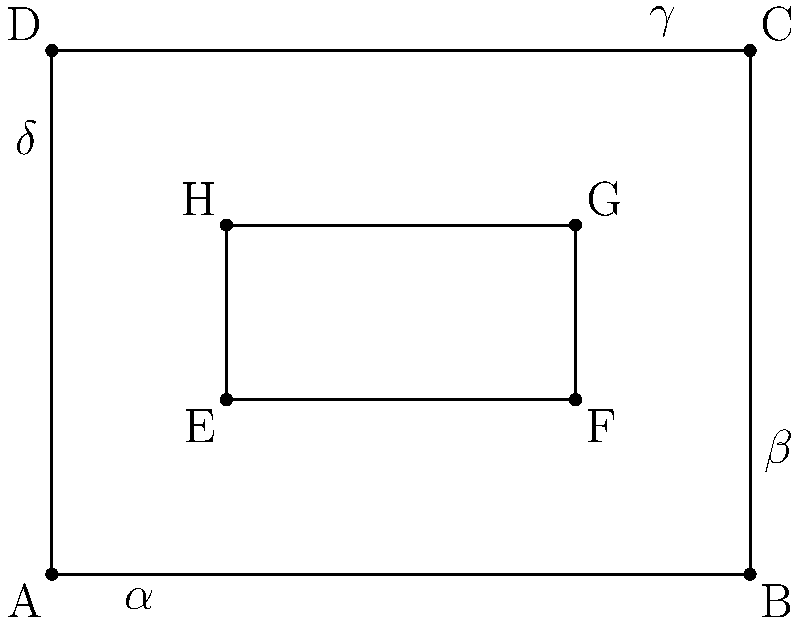In your high-end recording studio, you're designing an acoustic treatment layout. The room is represented by rectangle ABCD, with a sound-absorbing panel represented by rectangle EFGH. Angles $\alpha$, $\beta$, $\gamma$, and $\delta$ are formed at the corners of the room. Which pairs of angles are congruent, and why is this important for achieving balanced sound reflection? To determine the congruent angles and understand their importance in acoustic treatment, let's follow these steps:

1. Identify the shape of the room:
   The room is represented by rectangle ABCD.

2. Properties of a rectangle:
   - All interior angles of a rectangle are 90°.
   - Opposite sides are parallel and equal in length.

3. Congruent angles:
   - $\angle \alpha \cong \angle \gamma$ (opposite angles)
   - $\angle \beta \cong \angle \delta$ (opposite angles)

4. Why these angles are congruent:
   In a rectangle, opposite angles are congruent because they are formed by parallel lines intersecting at right angles.

5. Importance for balanced sound reflection:
   - Congruent angles ensure that sound waves reflect symmetrically in the room.
   - This symmetry helps create a more uniform sound field, reducing acoustic anomalies.
   - Balanced reflections contribute to accurate sound reproduction and monitoring.

6. Role of the sound-absorbing panel (EFGH):
   - The panel's placement affects how sound waves interact with the room's geometry.
   - Its position relative to the congruent angles can help fine-tune the acoustic treatment.

Understanding these congruent angles allows for strategic placement of acoustic treatments, ensuring that the studio's sound characteristics are consistent and professional-grade across the entire space.
Answer: $\angle \alpha \cong \angle \gamma$ and $\angle \beta \cong \angle \delta$; ensures balanced sound reflection 